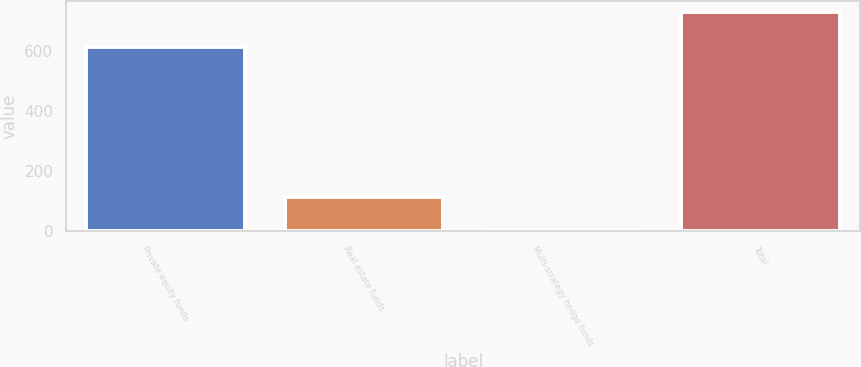Convert chart. <chart><loc_0><loc_0><loc_500><loc_500><bar_chart><fcel>Private equity funds<fcel>Real estate funds<fcel>Multi-strategy hedge funds<fcel>Total<nl><fcel>613<fcel>112<fcel>3<fcel>728<nl></chart> 